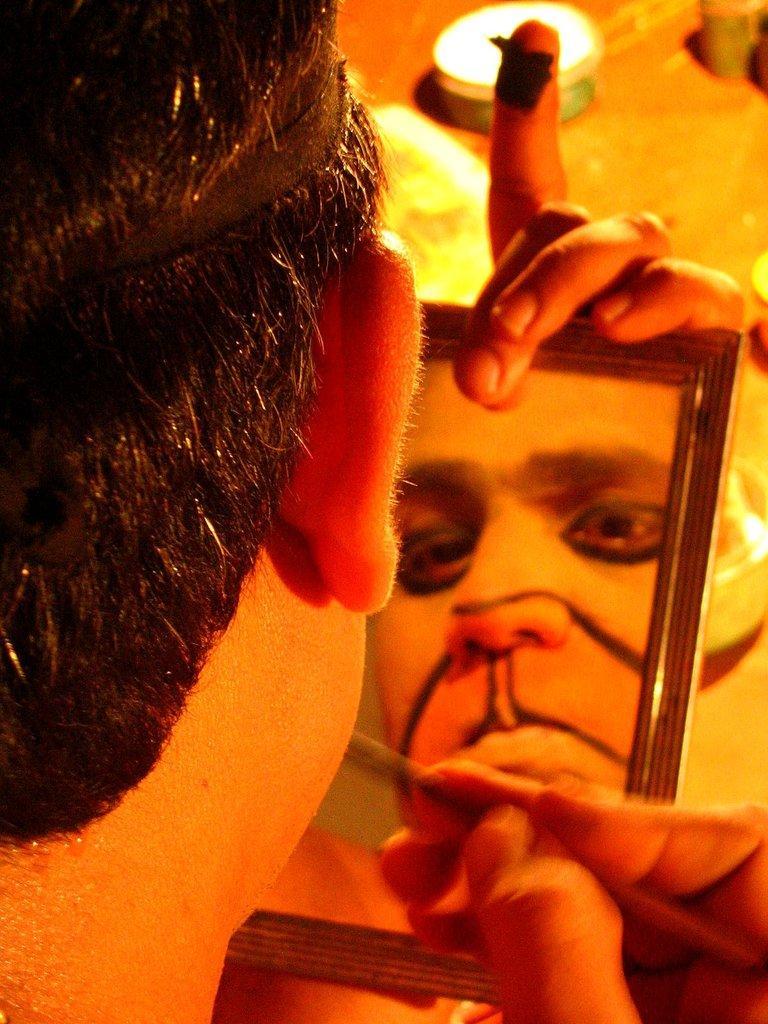Could you give a brief overview of what you see in this image? In this image we can see a person holding brush in the hands and his reflection in the mirror. 